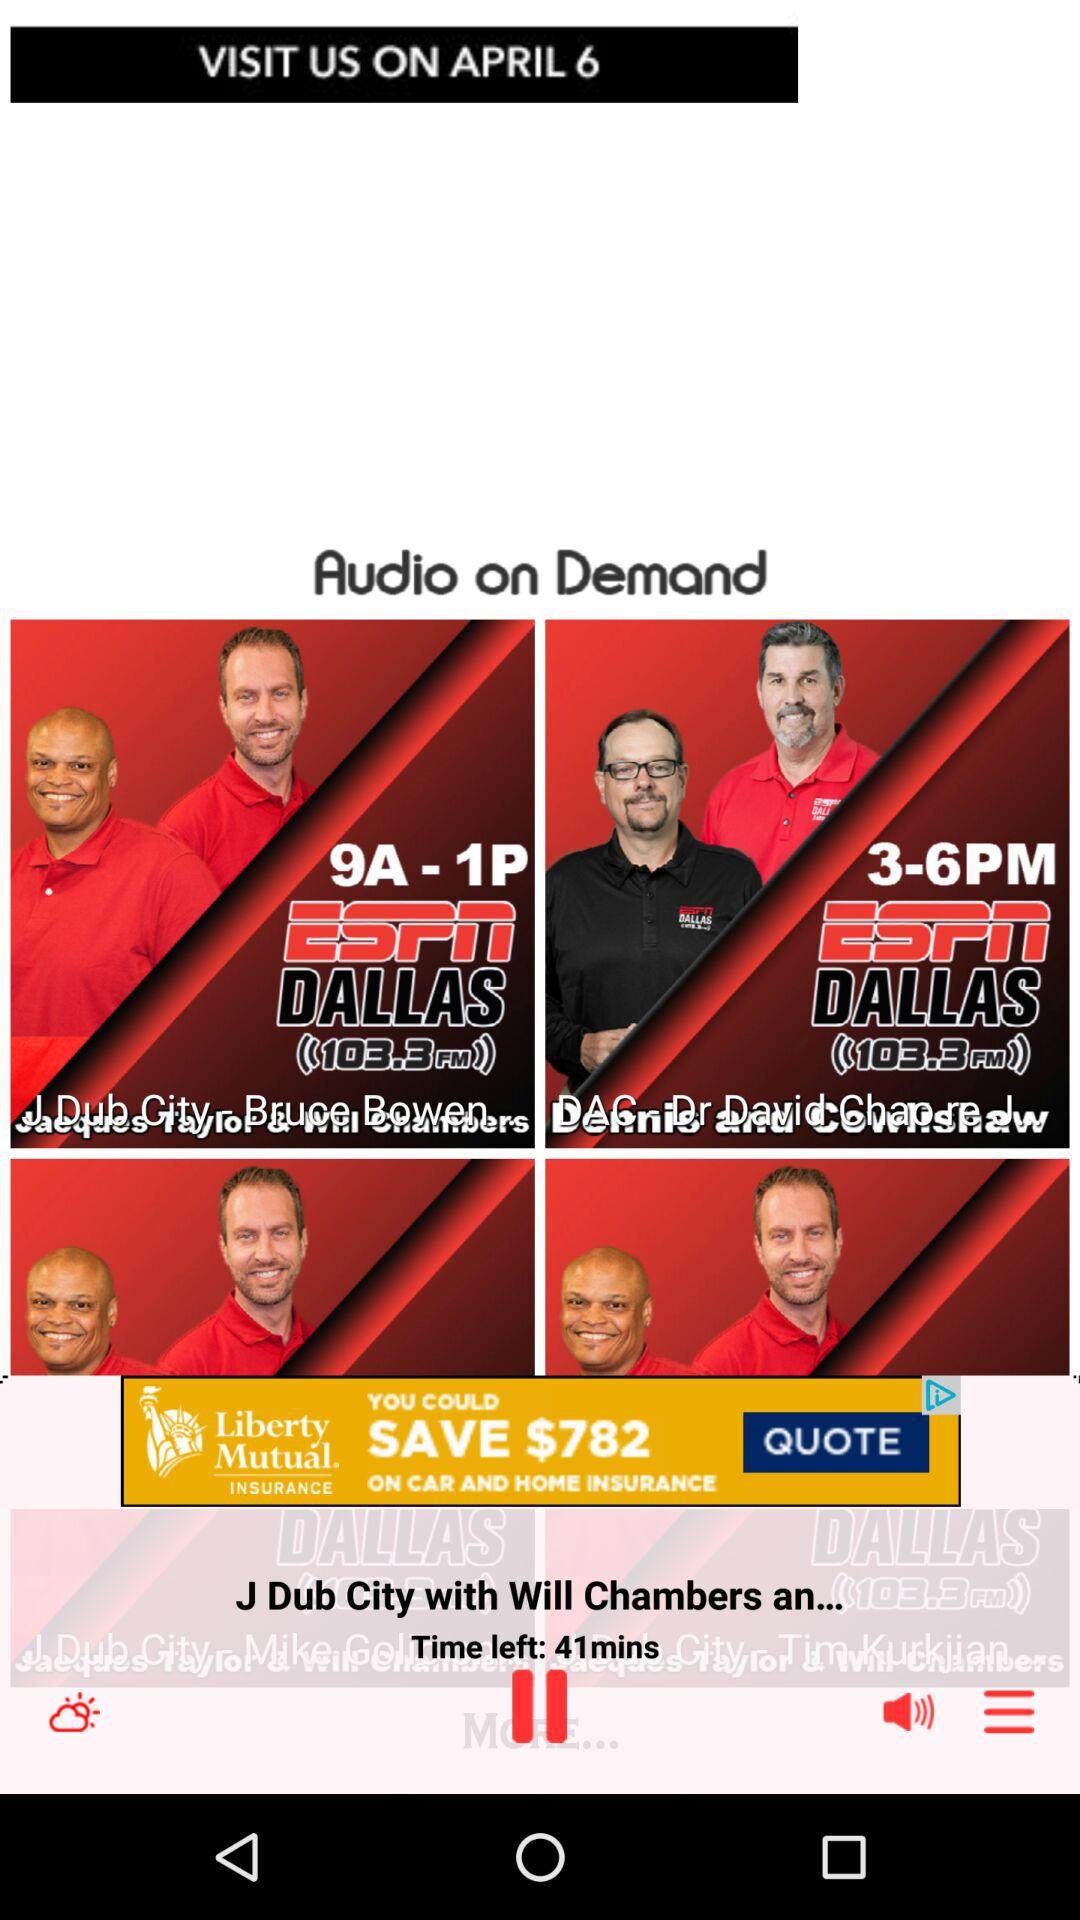Which audio has been currently playing? The currently playing audio is "J Dub City with Will Chambers an...". 